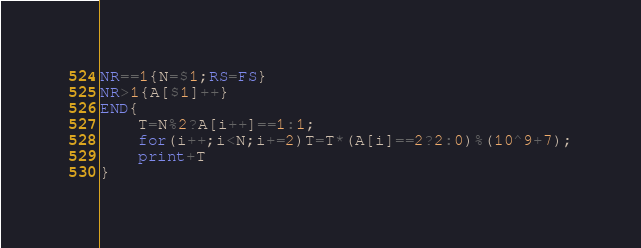Convert code to text. <code><loc_0><loc_0><loc_500><loc_500><_Awk_>NR==1{N=$1;RS=FS}
NR>1{A[$1]++}
END{
	T=N%2?A[i++]==1:1;
	for(i++;i<N;i+=2)T=T*(A[i]==2?2:0)%(10^9+7);
	print+T
}</code> 